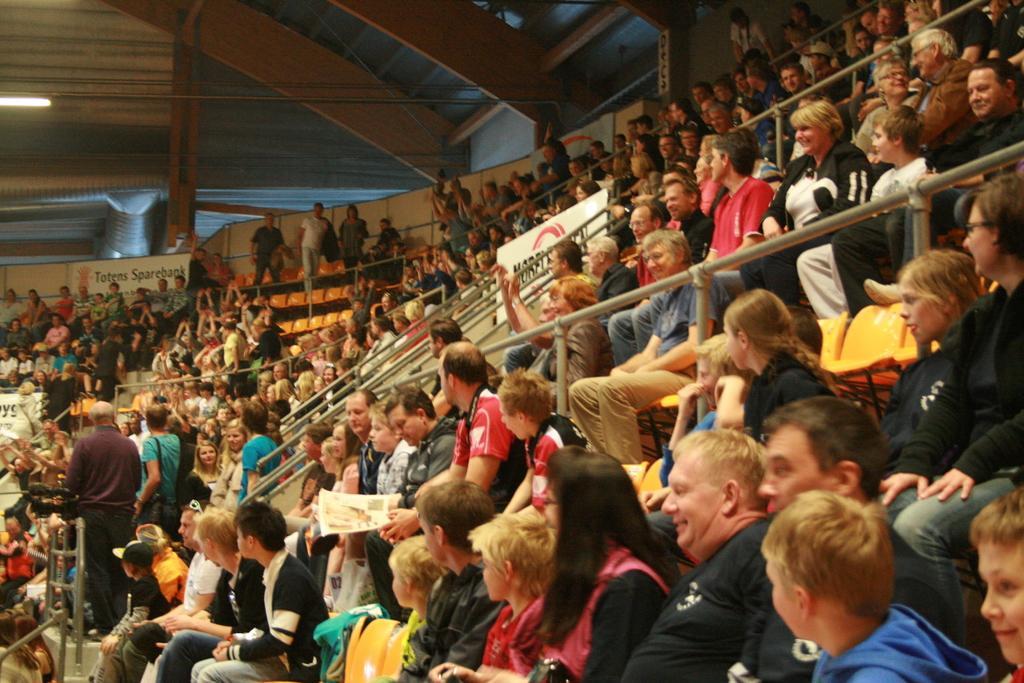In one or two sentences, can you explain what this image depicts? In the image there are many people sitting on a chair looking at a game, this is clicked inside a auditorium, there are lights over the ceiling. 